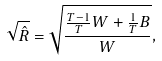<formula> <loc_0><loc_0><loc_500><loc_500>\sqrt { \hat { R } } = \sqrt { \frac { \frac { T - 1 } { T } W + \frac { 1 } { T } B } { W } } ,</formula> 